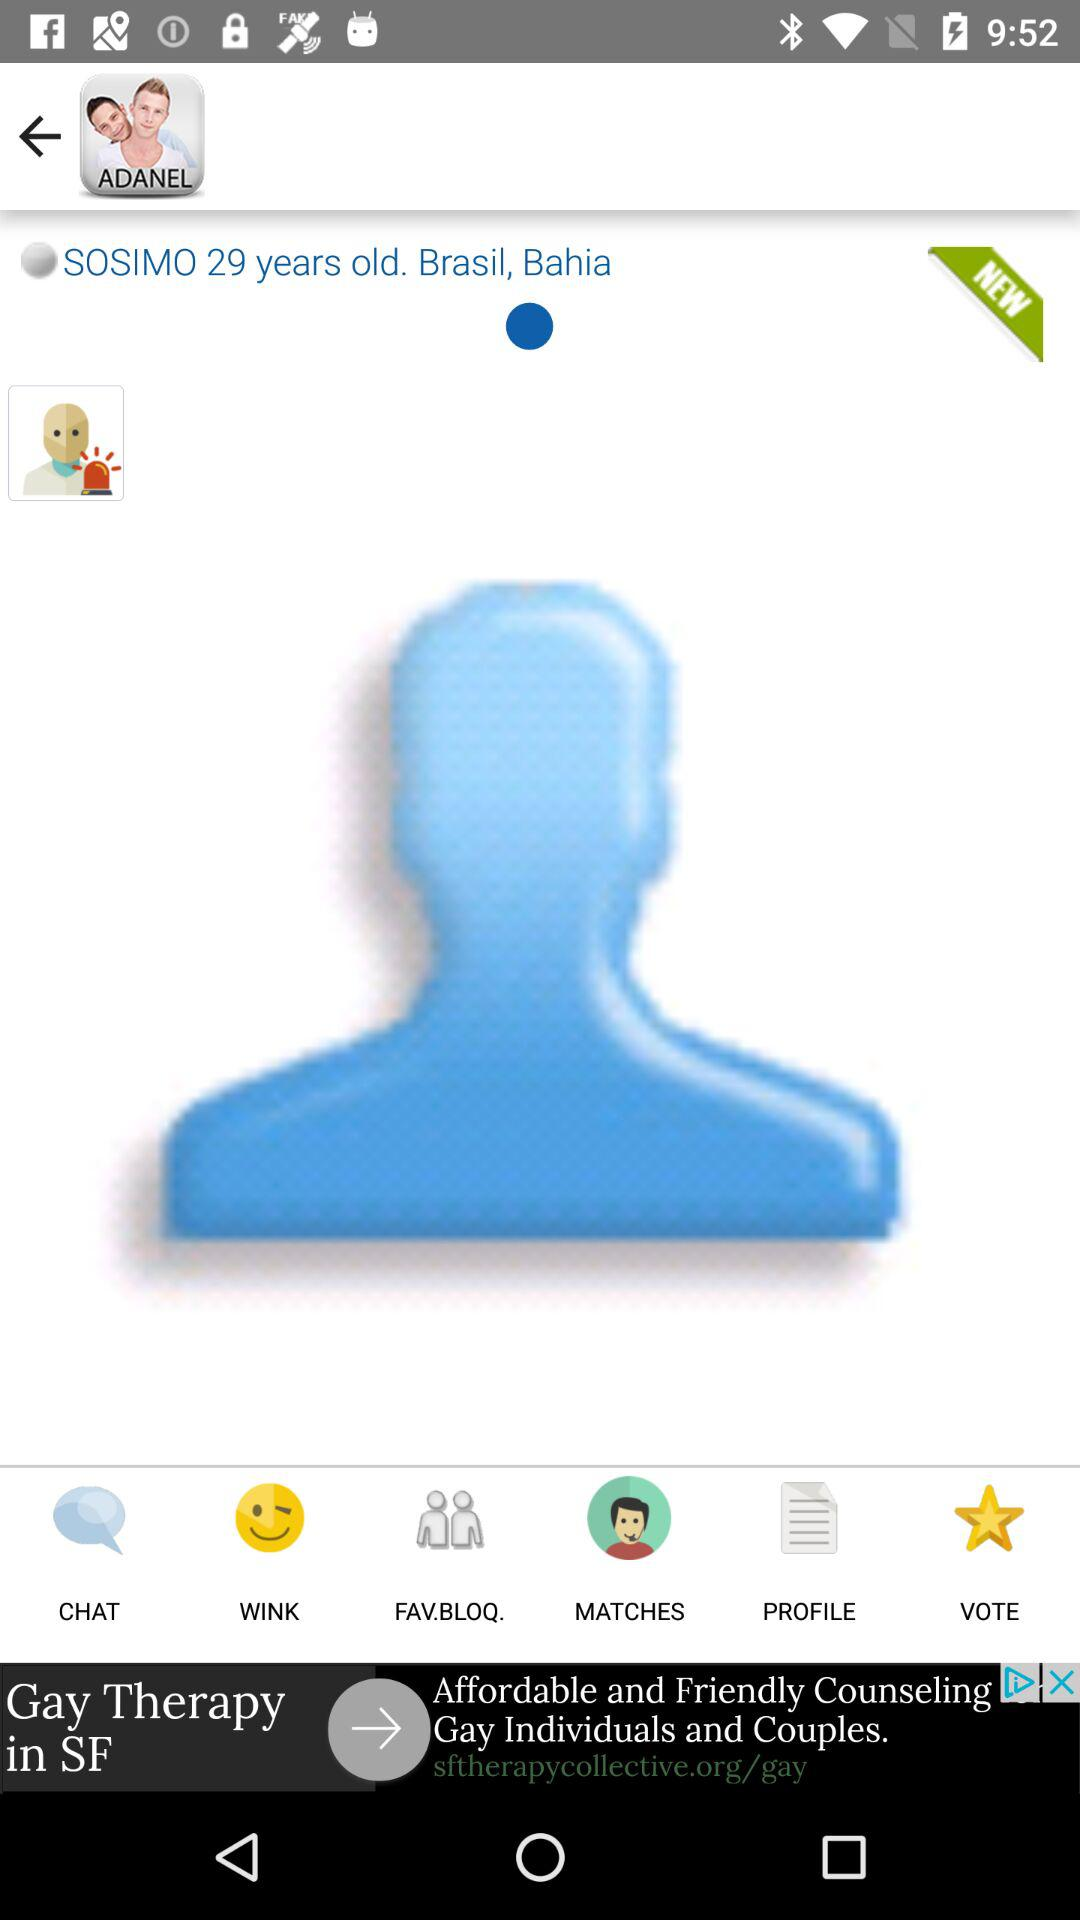Where is Sosimo from? Sosimo is from Bahia, Brasil. 